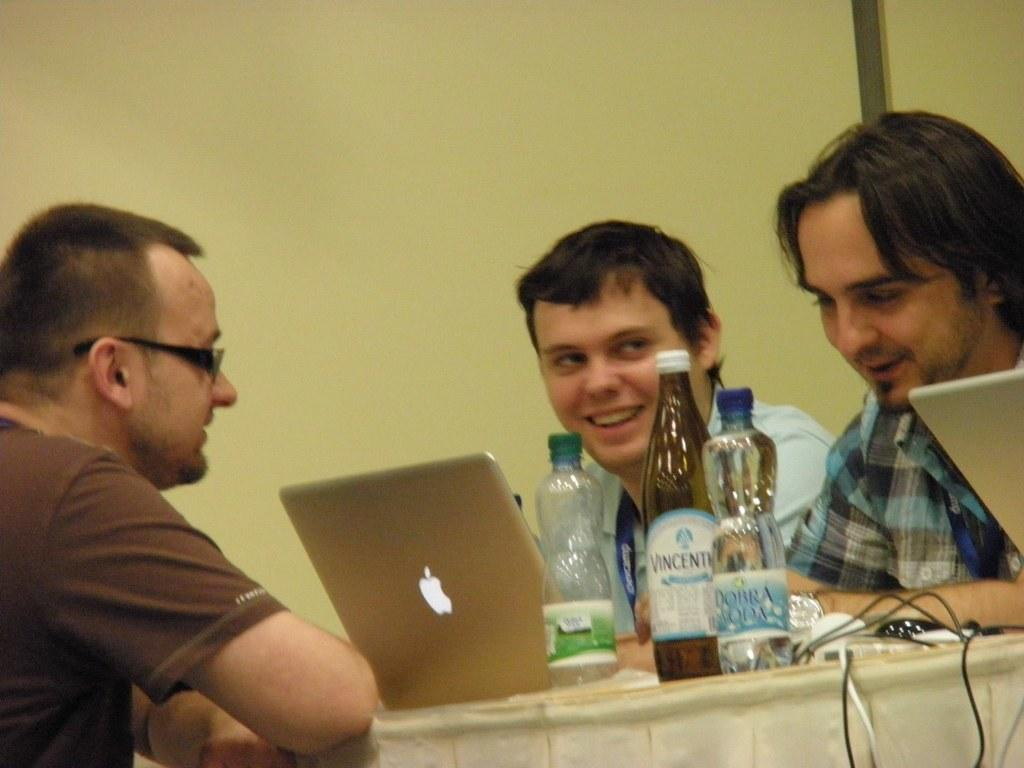How many men are in the image? There are three men in the image. What are the men doing in the image? The men are sitting on chairs. What can be seen on the table in the image? There are three bottles and at least two laptops on the table. What is the facial expression of the men in the image? The men are smiling. Can you describe one of the men's appearance? One of the men is wearing spectacles. What type of gold jewelry is the man wearing in the image? There is no gold jewelry visible on any of the men in the image. How many cattle can be seen grazing in the background of the image? There are no cattle present in the image; it features three men sitting on chairs with a table in front of them. 